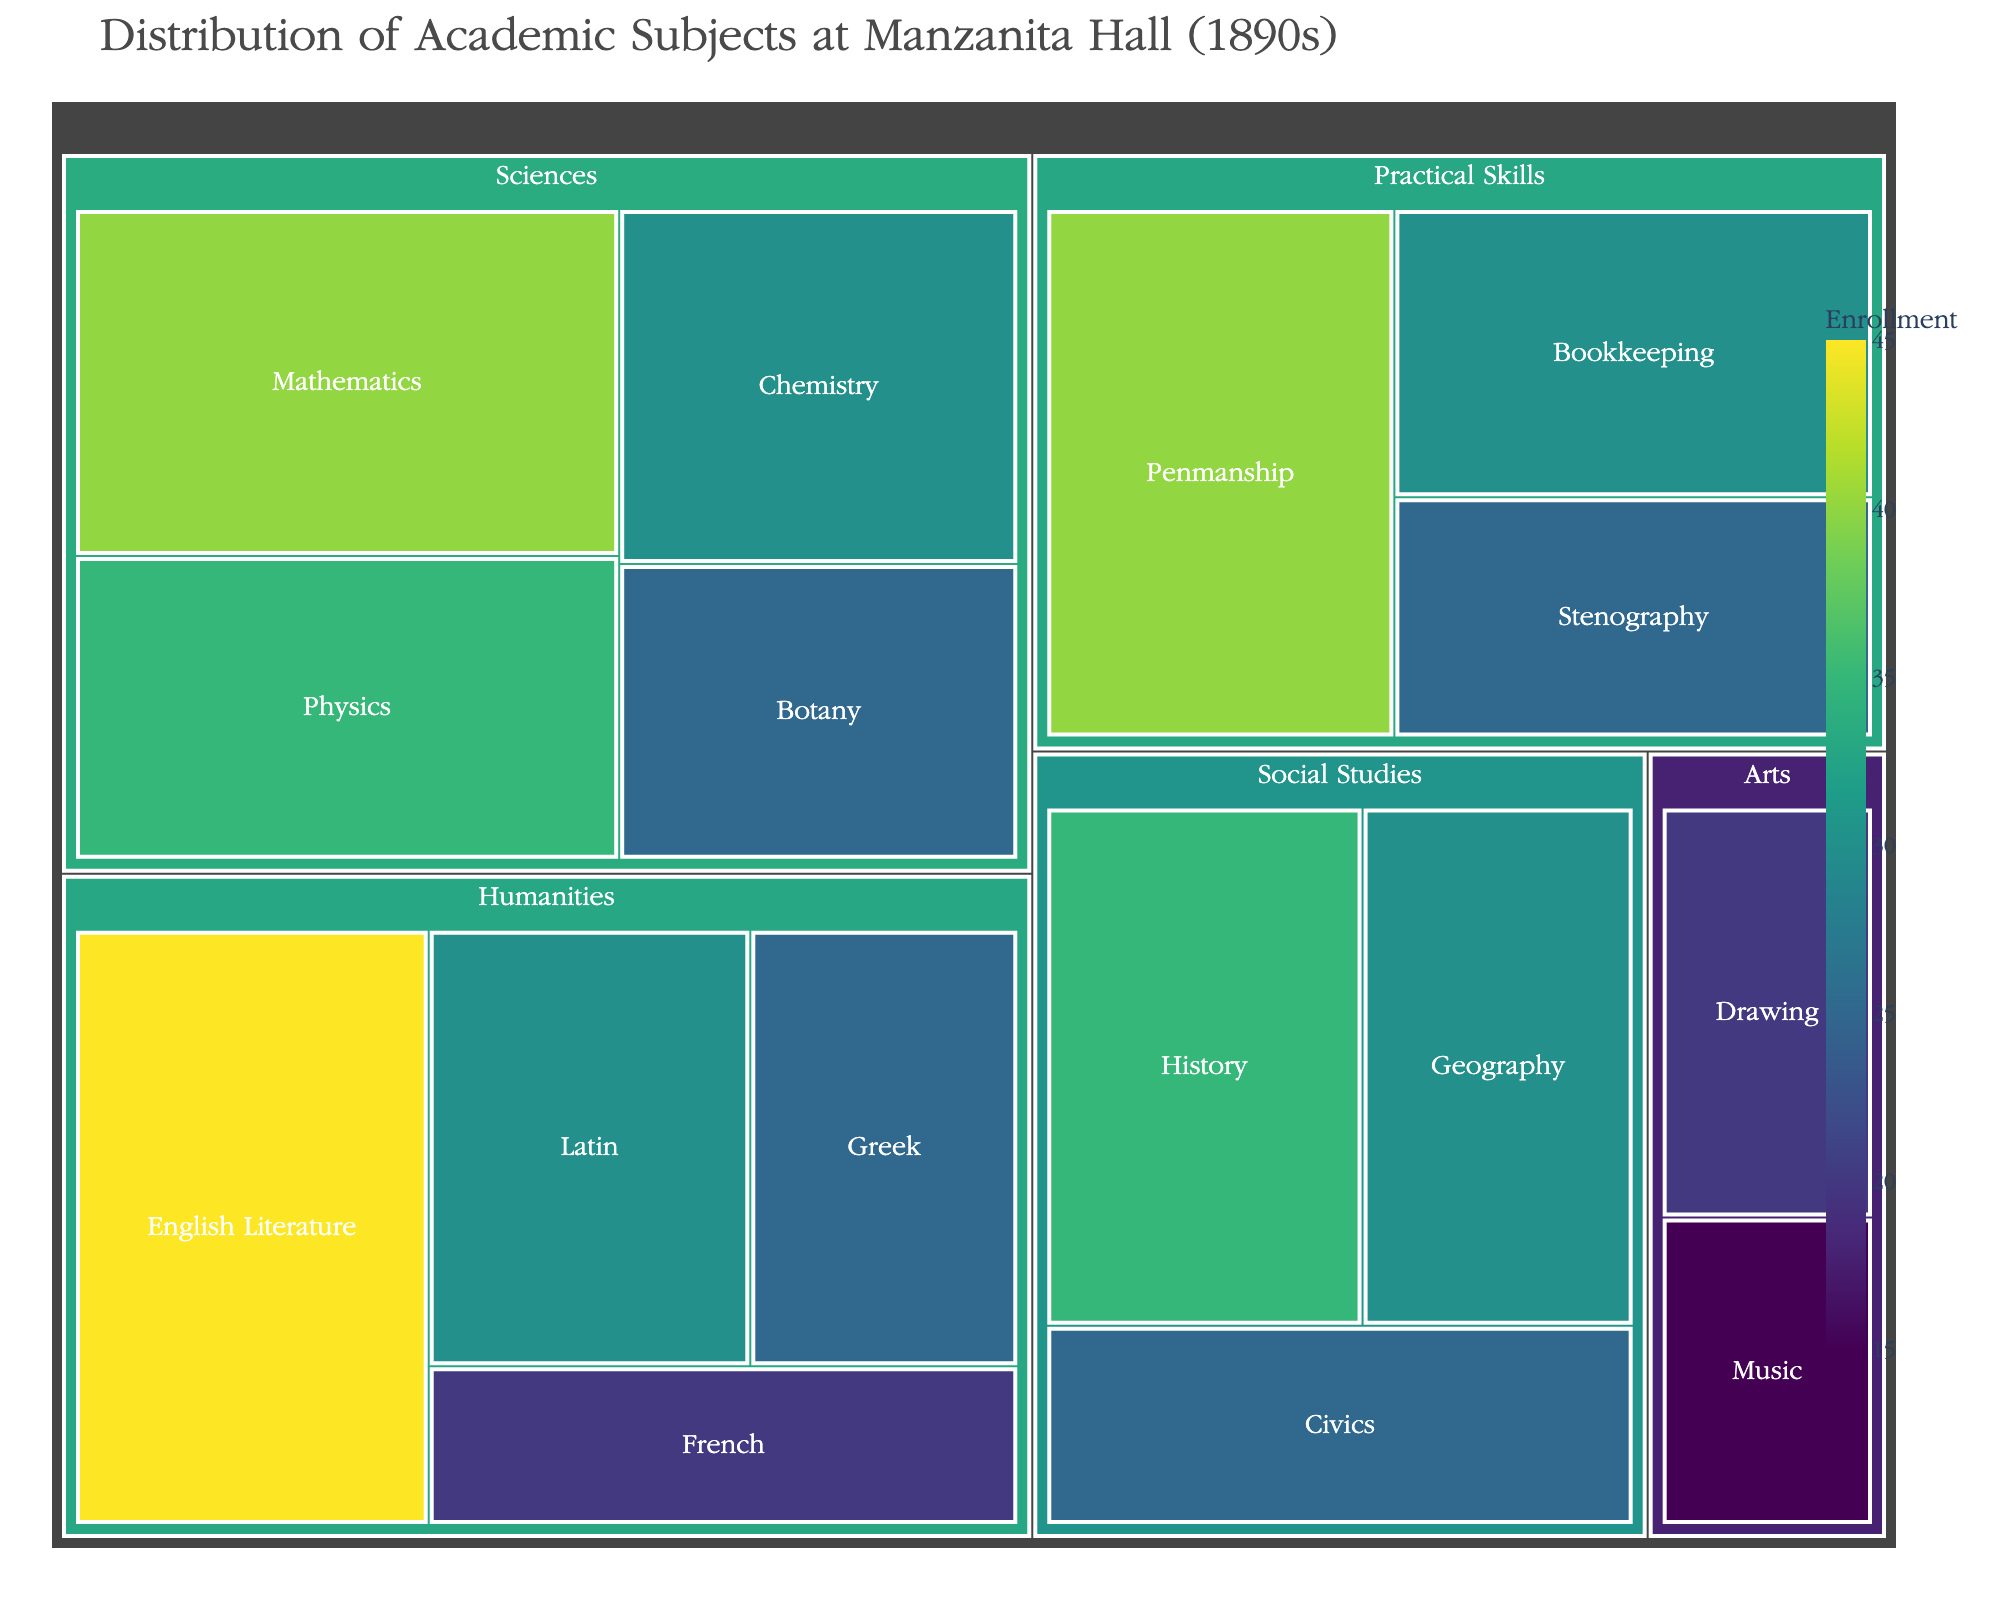What is the title of the treemap? The title is generally located at the top of the treemap, and it is intended to provide a summary of what the plot represents.
Answer: Distribution of Academic Subjects at Manzanita Hall (1890s) Which subject in the Humanities department has the highest enrollment? By examining the Humanities section in the treemap, identify the subject with the largest area, as the area represents enrollment.
Answer: English Literature How many subjects are there in the Sciences department? Count all the distinct sections within the Sciences category to determine the total number of subjects.
Answer: 4 Which department has the subject with the smallest enrollment? Identify the smallest individual section across all departments and note the department it belongs to.
Answer: Arts What is the combined enrollment of the Practical Skills department? Add together the enrollment figures for all subjects within the Practical Skills department: Penmanship (40), Bookkeeping (30), and Stenography (25). The total is 40 + 30 + 25 = 95.
Answer: 95 Compare the enrollment in History and Geography. Which is higher? Locate History and Geography within the Social Studies department, and compare the sizes or values presented for each.
Answer: History What is the average enrollment of the subjects in the Arts department? Sum the enrollments of Drawing (20) and Music (15), then divide by the number of subjects in the department. The calculation is (20 + 15) / 2 = 17.5.
Answer: 17.5 Which department has the highest overall enrollment? Sum the enrollments of each subject within all departments, and compare to determine which department has the highest total. Practical Skills: 95, Sciences: 130, Humanities: 120, Social Studies: 90, Arts: 35. The highest is Sciences with 130.
Answer: Sciences Which subject has the lowest enrollment across all departments? Identify the smallest individual section in the entire treemap, representing the subject with the lowest number.
Answer: Music If the enrollment in English Literature and Mathematics were combined, what would be their total enrollment? Add the enrollment figures for English Literature (45) and Mathematics (40). The total is 45 + 40 = 85.
Answer: 85 